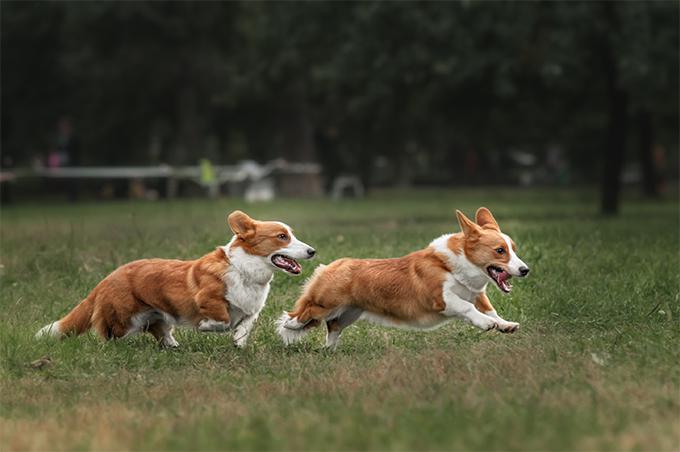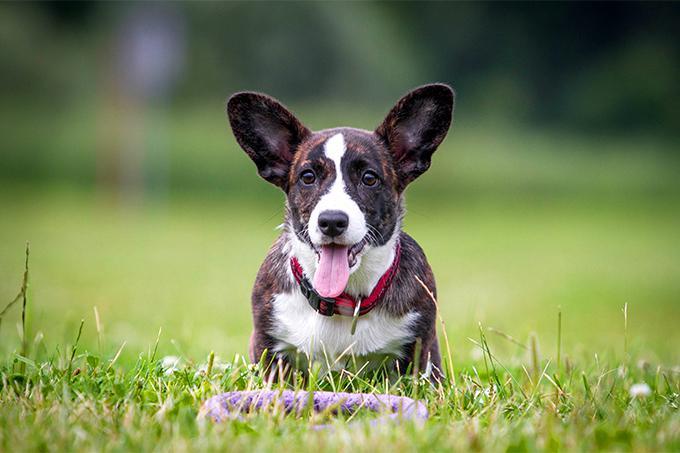The first image is the image on the left, the second image is the image on the right. Examine the images to the left and right. Is the description "All dogs shown are on the grass, and at least two dogs in total have their mouths open and tongues showing." accurate? Answer yes or no. Yes. The first image is the image on the left, the second image is the image on the right. Evaluate the accuracy of this statement regarding the images: "At least one dog is sticking the tongue out.". Is it true? Answer yes or no. Yes. 